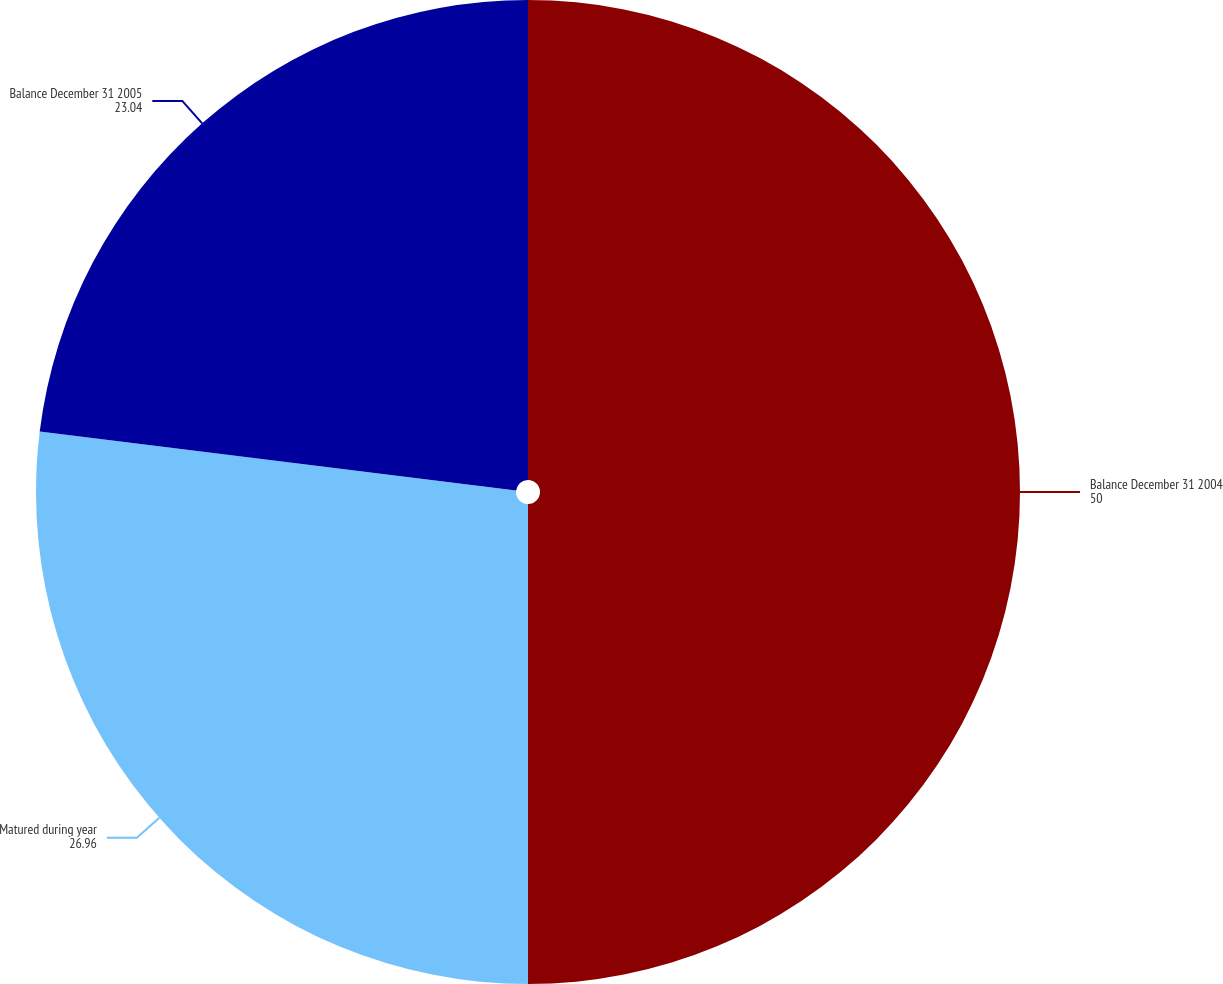<chart> <loc_0><loc_0><loc_500><loc_500><pie_chart><fcel>Balance December 31 2004<fcel>Matured during year<fcel>Balance December 31 2005<nl><fcel>50.0%<fcel>26.96%<fcel>23.04%<nl></chart> 